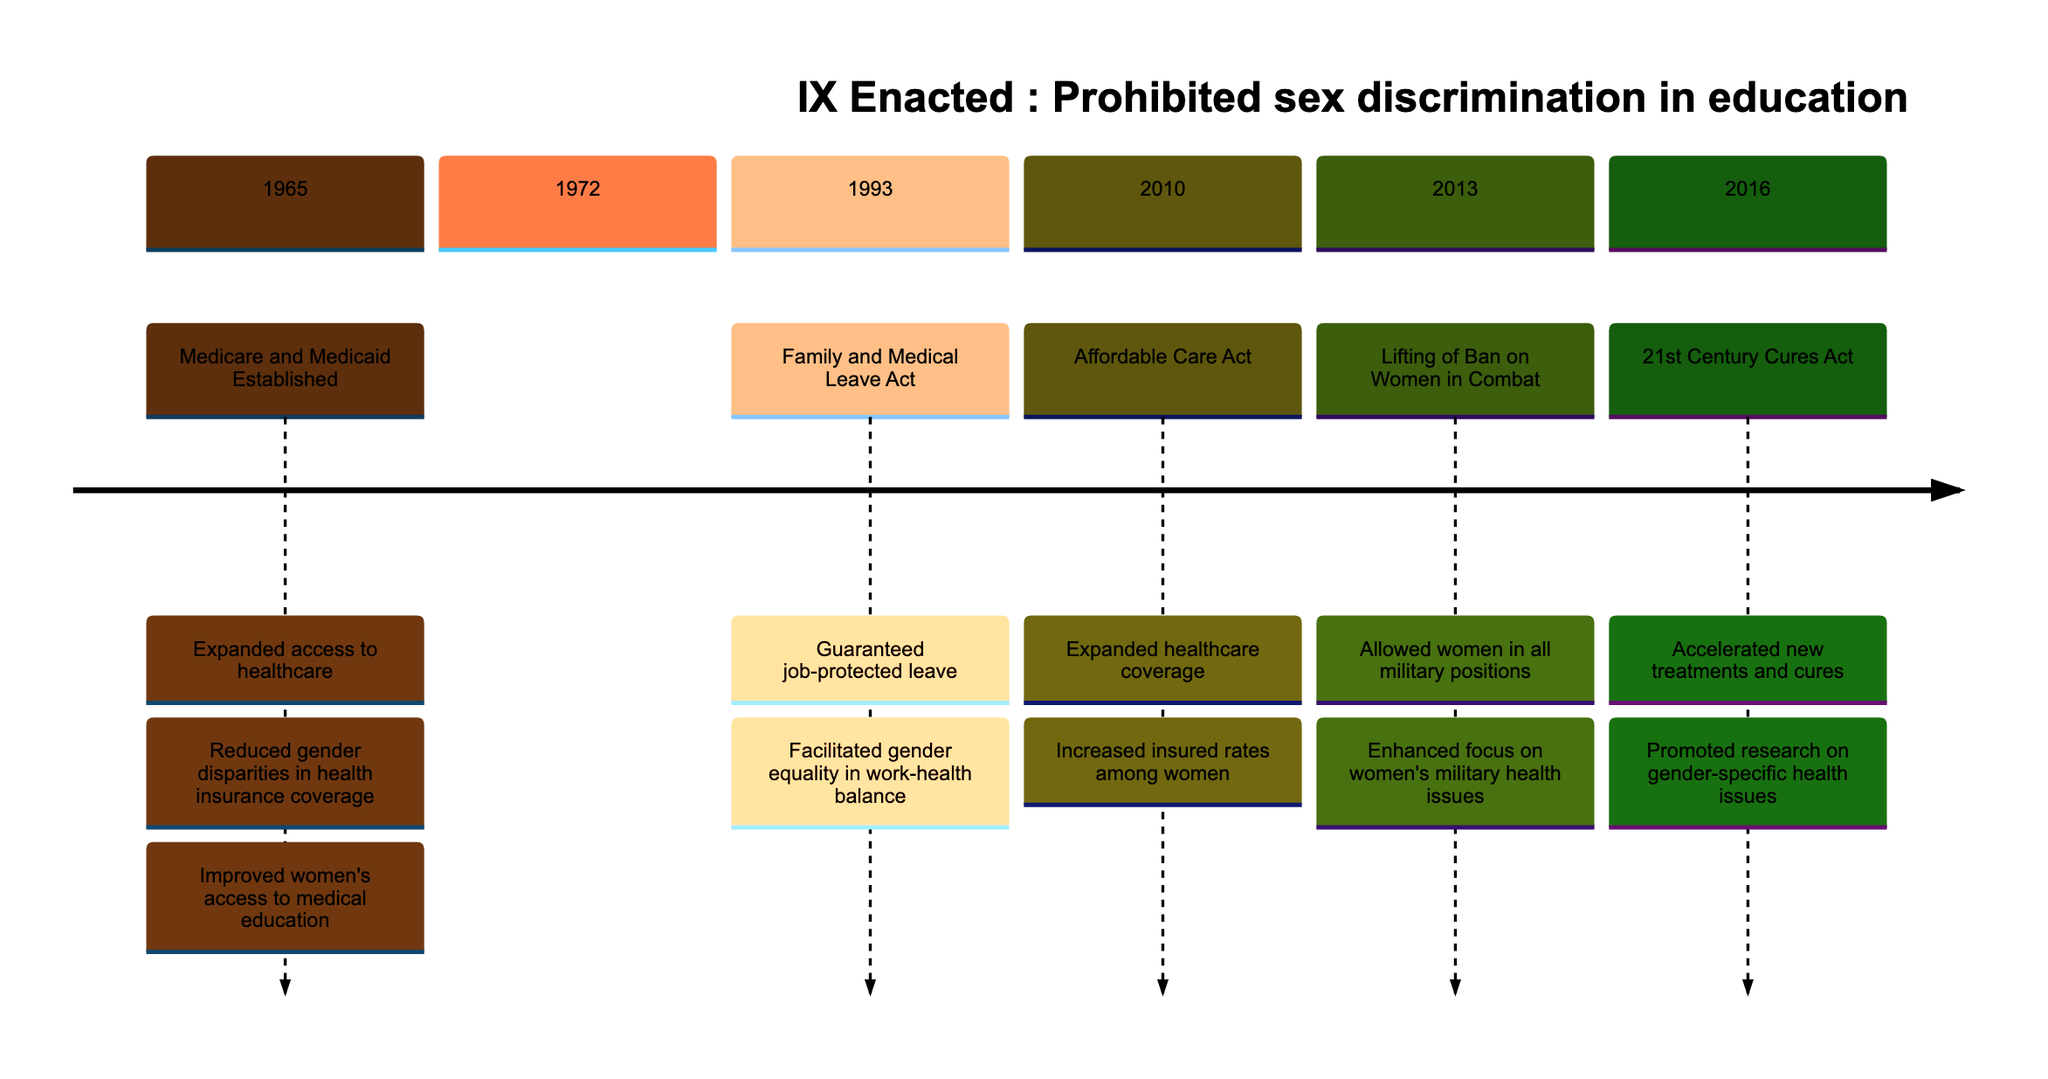What key policy was established in 1965? The diagram clearly lists "Medicare and Medicaid Established" as a key policy in 1965. This is straightforward since it is directly stated under the section for that year.
Answer: Medicare and Medicaid Established What was one sociological impact of the Affordable Care Act in 2010? The Affordable Care Act's sociological impact is noted as "Increased insured rates among women," which is explicitly mentioned in the corresponding section of the diagram.
Answer: Increased insured rates among women How many key health policy changes are listed in the timeline? By counting the distinct sections labeled with years in the timeline, there are 6 sections (1965, 1972, 1993, 2010, 2013, 2016), thus indicating 6 key policy changes.
Answer: 6 What year did Title IX get enacted? The timeline specifies that Title IX was enacted in 1972, which directly answers the question based on the information provided in that section.
Answer: 1972 Which policy in 2013 focused on women's military health issues? The diagram notes "Lifting of Ban on Women in Combat" in 2013, with a corresponding impact that mentions an enhanced focus on women's military health issues. This makes it clear that this policy relates to that area.
Answer: Lifting of Ban on Women in Combat Which policy did '21st Century Cures Act' expedite? The description under the 21st Century Cures Act states it "Accelerated new treatments and cures," indicating that there was an emphasis on speeding up the development of medical treatments, but it does not specify a particular policy that it expedited. Therefore, it focuses on the general impact rather than a specific policy related to gender.
Answer: Accelerated new treatments and cures What are the two main impacts mentioned for the 1993 Family and Medical Leave Act? The diagram outlines two impacts: "Guaranteed job-protected leave" and "Facilitated gender equality in work-health balance." Both are explicitly stated in the section for 1993, answering the question directly.
Answer: Guaranteed job-protected leave; Facilitated gender equality in work-health balance Which policy in 2016 promoted research on gender-specific health issues? The 21st Century Cures Act, noted in the year 2016, is indicated to have promoted research specifically focused on gender-specific health issues, which answers the question effectively.
Answer: 21st Century Cures Act 